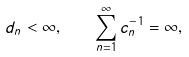<formula> <loc_0><loc_0><loc_500><loc_500>d _ { n } < \infty , \quad \sum _ { n = 1 } ^ { \infty } c _ { n } ^ { - 1 } = \infty ,</formula> 